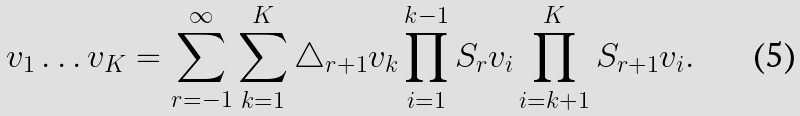<formula> <loc_0><loc_0><loc_500><loc_500>v _ { 1 } \dots v _ { K } = \sum ^ { \infty } _ { r = - 1 } \sum ^ { K } _ { k = 1 } \triangle _ { r + 1 } v _ { k } \prod ^ { k - 1 } _ { i = 1 } S _ { r } v _ { i } \prod ^ { K } _ { i = k + 1 } S _ { r + 1 } v _ { i } .</formula> 